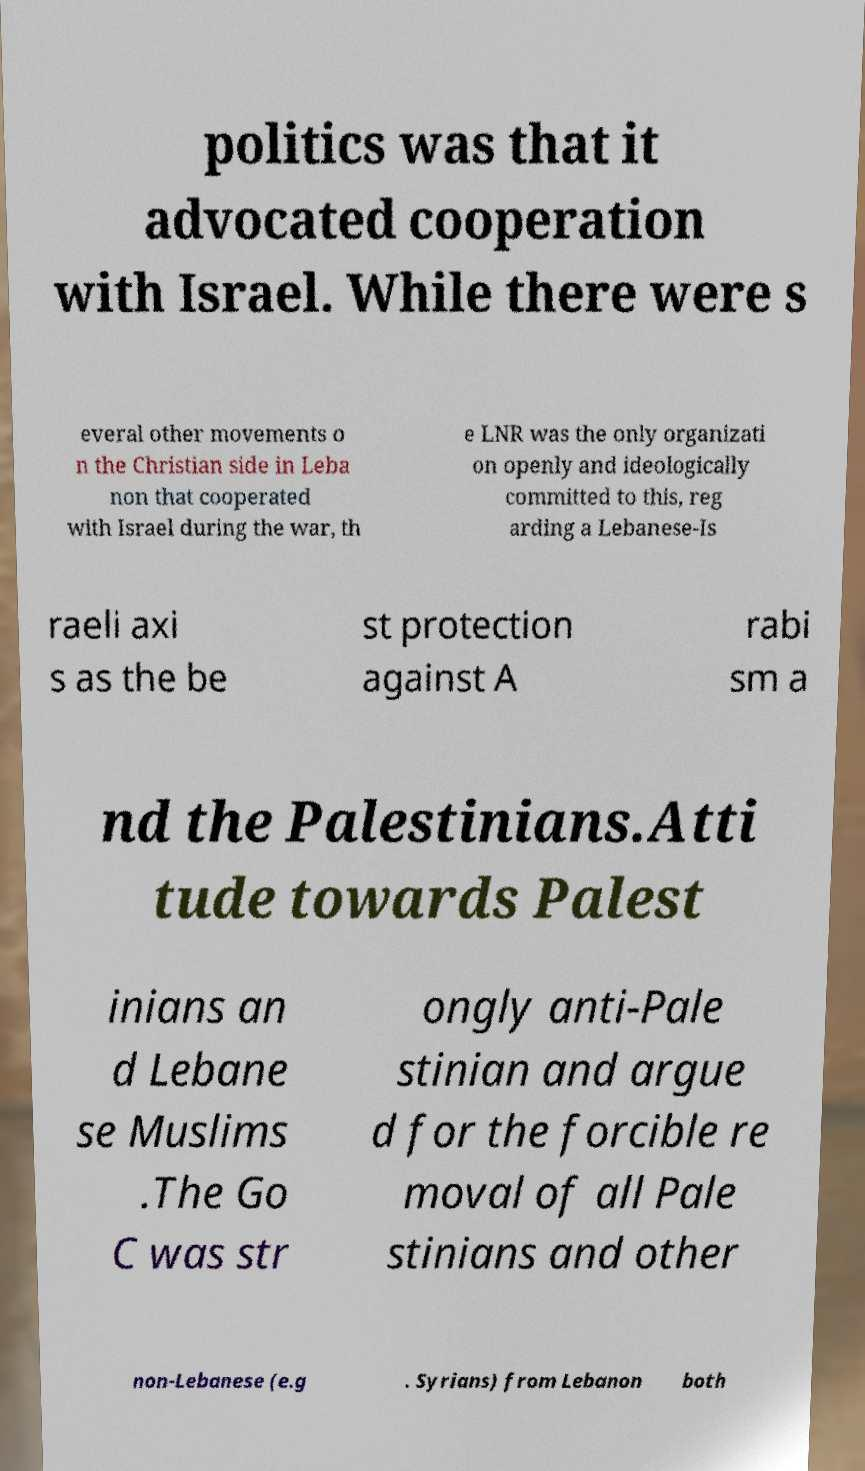Please identify and transcribe the text found in this image. politics was that it advocated cooperation with Israel. While there were s everal other movements o n the Christian side in Leba non that cooperated with Israel during the war, th e LNR was the only organizati on openly and ideologically committed to this, reg arding a Lebanese-Is raeli axi s as the be st protection against A rabi sm a nd the Palestinians.Atti tude towards Palest inians an d Lebane se Muslims .The Go C was str ongly anti-Pale stinian and argue d for the forcible re moval of all Pale stinians and other non-Lebanese (e.g . Syrians) from Lebanon both 